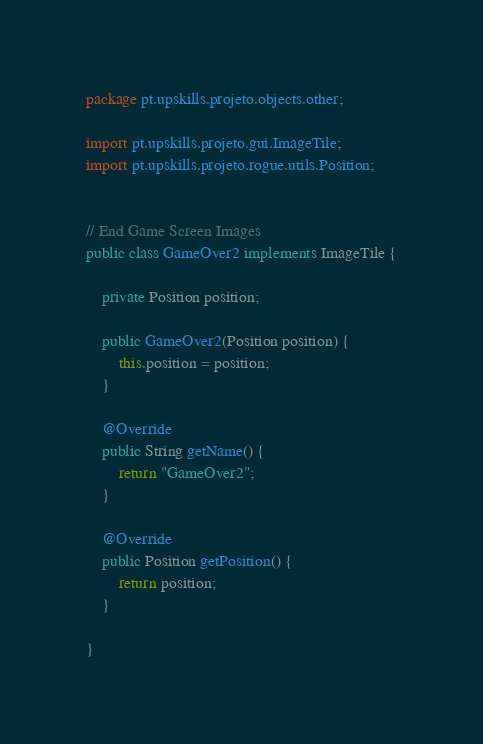Convert code to text. <code><loc_0><loc_0><loc_500><loc_500><_Java_>package pt.upskills.projeto.objects.other;

import pt.upskills.projeto.gui.ImageTile;
import pt.upskills.projeto.rogue.utils.Position;


// End Game Screen Images
public class GameOver2 implements ImageTile {

    private Position position;

    public GameOver2(Position position) {
        this.position = position;
    }

    @Override
    public String getName() {
        return "GameOver2";
    }

    @Override
    public Position getPosition() {
        return position;
    }

}
</code> 